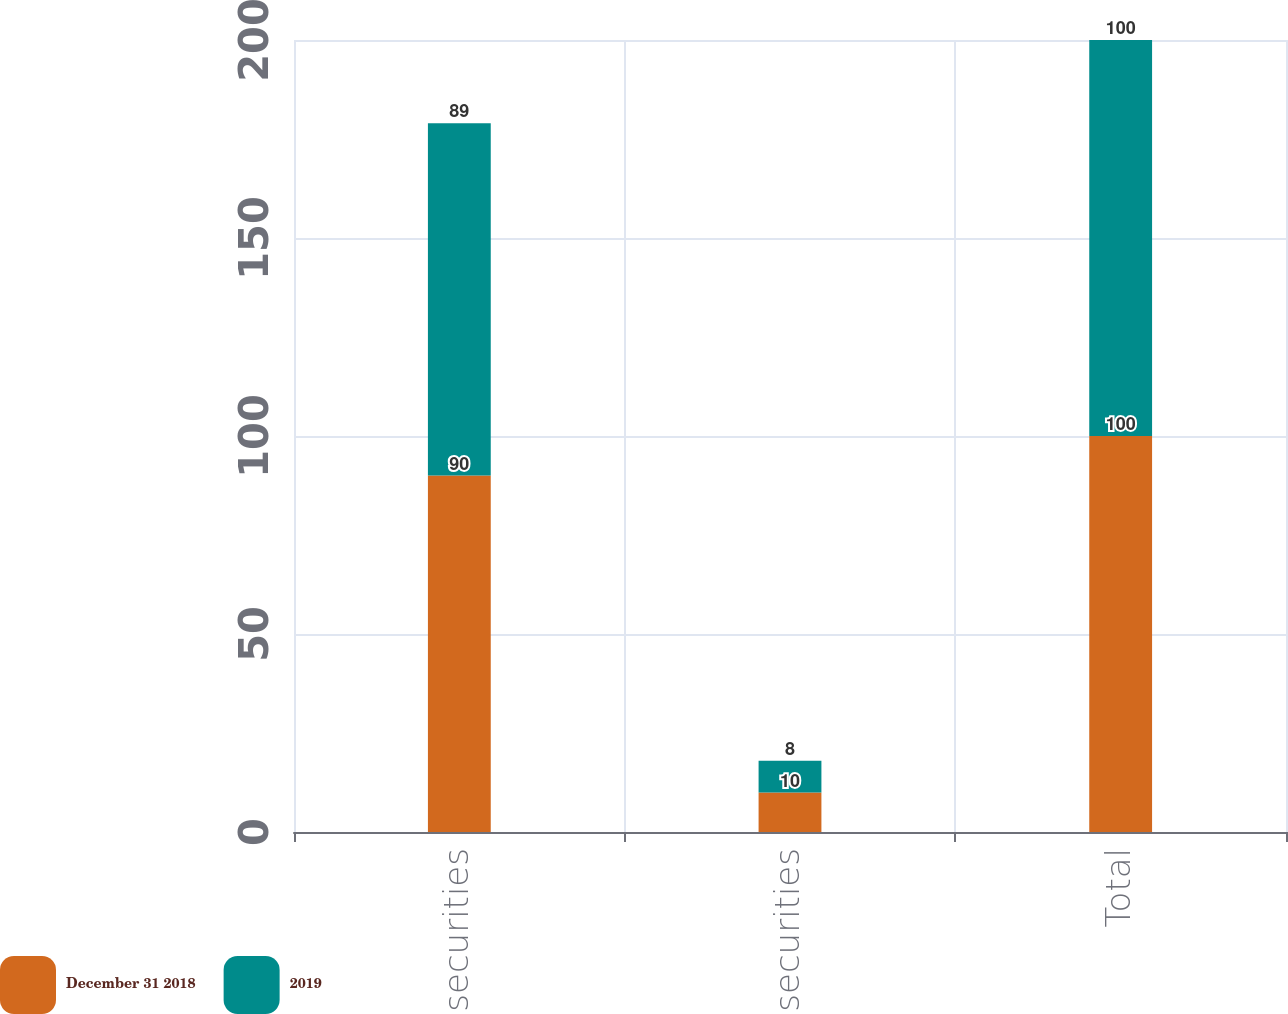Convert chart to OTSL. <chart><loc_0><loc_0><loc_500><loc_500><stacked_bar_chart><ecel><fcel>Debt securities<fcel>US equity securities<fcel>Total<nl><fcel>December 31 2018<fcel>90<fcel>10<fcel>100<nl><fcel>2019<fcel>89<fcel>8<fcel>100<nl></chart> 